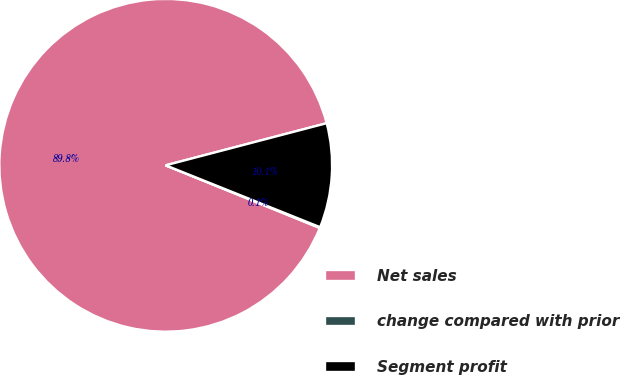Convert chart to OTSL. <chart><loc_0><loc_0><loc_500><loc_500><pie_chart><fcel>Net sales<fcel>change compared with prior<fcel>Segment profit<nl><fcel>89.78%<fcel>0.08%<fcel>10.14%<nl></chart> 